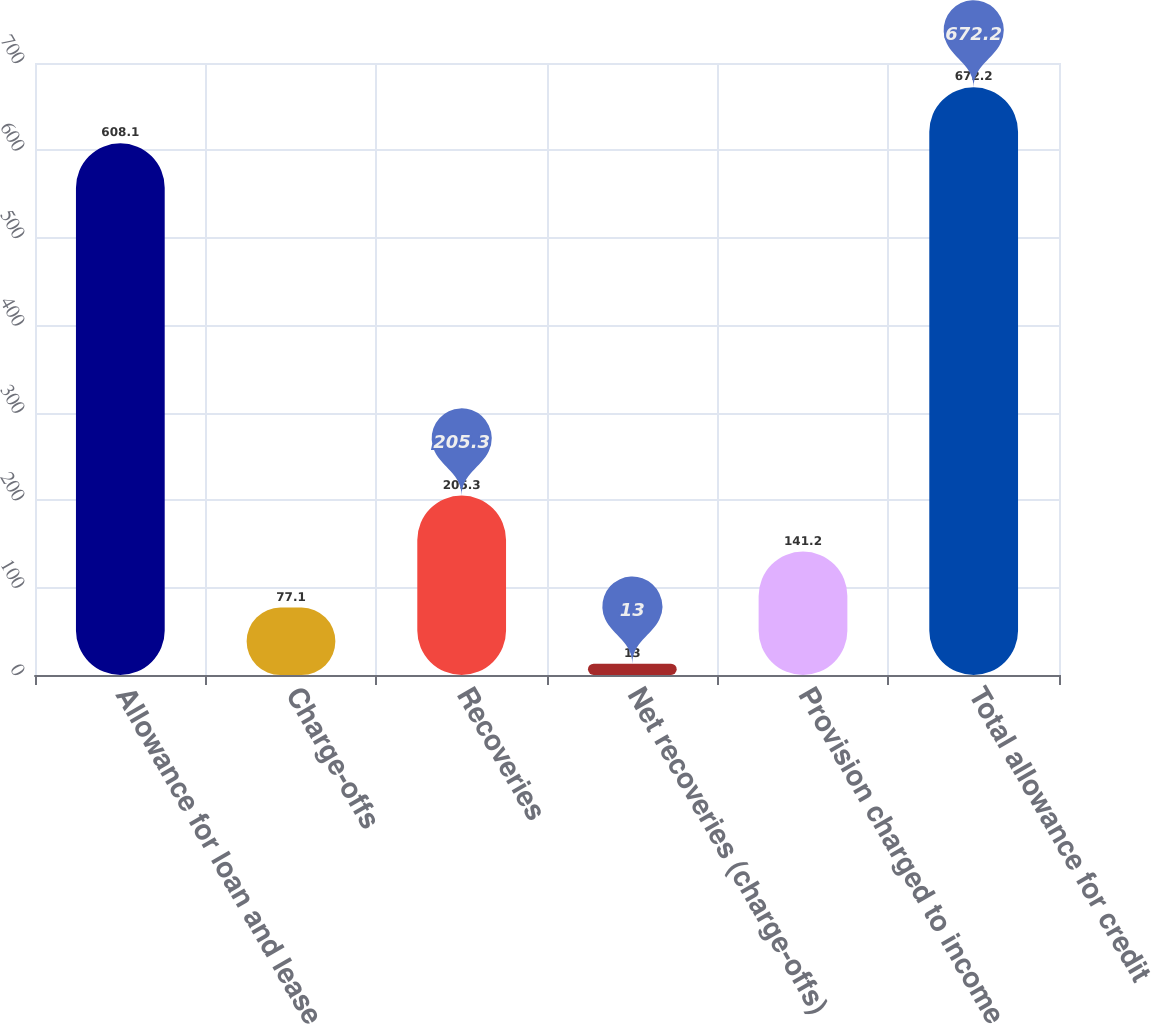Convert chart to OTSL. <chart><loc_0><loc_0><loc_500><loc_500><bar_chart><fcel>Allowance for loan and lease<fcel>Charge-offs<fcel>Recoveries<fcel>Net recoveries (charge-offs)<fcel>Provision charged to income<fcel>Total allowance for credit<nl><fcel>608.1<fcel>77.1<fcel>205.3<fcel>13<fcel>141.2<fcel>672.2<nl></chart> 